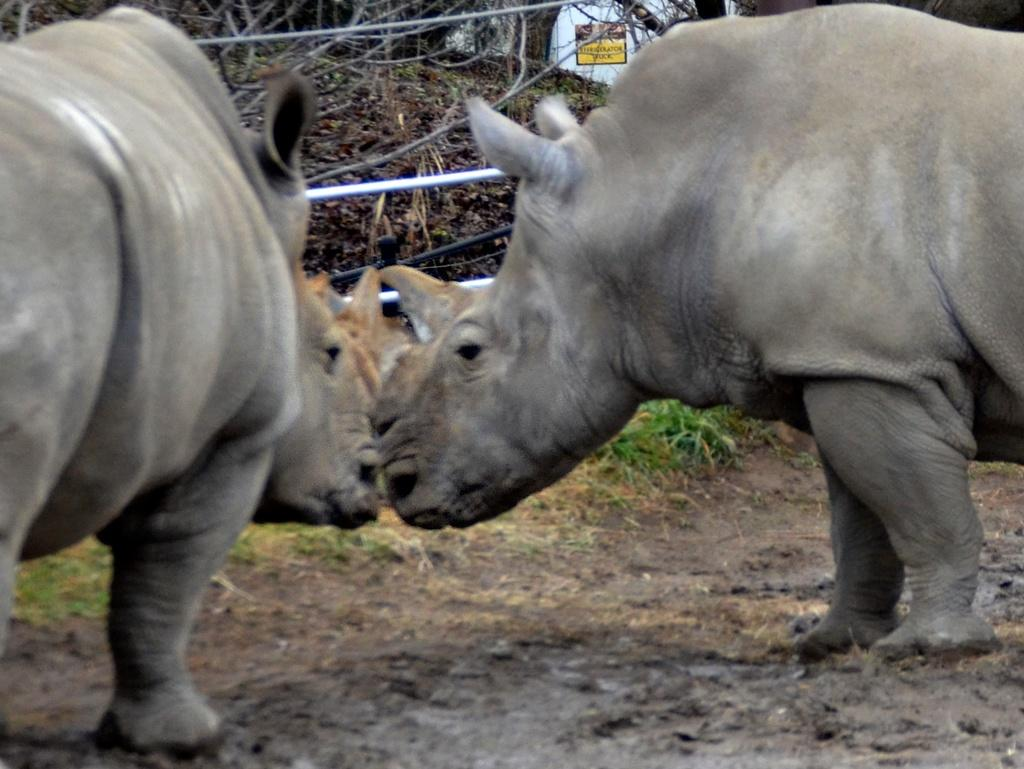How many animals are present in the image? There are two animals in the image. What is the color of the animals? The animals are black in color. What can be seen in the background of the image? There are plants and a board in the background of the image. What type of engine can be seen powering the animals in the image? There is no engine present in the image, and the animals are not being powered by any external force. 